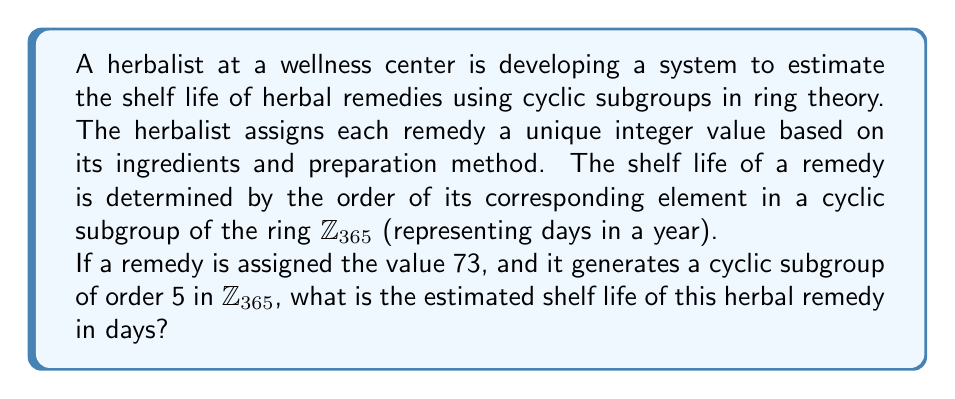Teach me how to tackle this problem. To solve this problem, we need to understand the concept of cyclic subgroups in the ring $\mathbb{Z}_{365}$ and how they relate to the shelf life of herbal remedies.

1. In the ring $\mathbb{Z}_{365}$, we are working with integers modulo 365.

2. The cyclic subgroup generated by 73 is:
   $\langle 73 \rangle = \{73, 146, 219, 292, 0\}$ (mod 365)

3. We can verify this:
   $73 \times 1 = 73$ (mod 365)
   $73 \times 2 = 146$ (mod 365)
   $73 \times 3 = 219$ (mod 365)
   $73 \times 4 = 292$ (mod 365)
   $73 \times 5 = 365 \equiv 0$ (mod 365)

4. The order of this subgroup is 5, which means that after 5 applications of the generating element (73), we return to the identity element (0) in the ring.

5. In the context of herbal remedies, each application of the generating element represents one shelf life cycle. The total number of elements in the subgroup (excluding 0) represents the number of shelf life cycles.

6. Since there are 4 non-zero elements in the subgroup, and each element represents 73 days, we can calculate the total shelf life as follows:

   Shelf life = 4 × 73 = 292 days

Therefore, the estimated shelf life of the herbal remedy is 292 days.
Answer: 292 days 